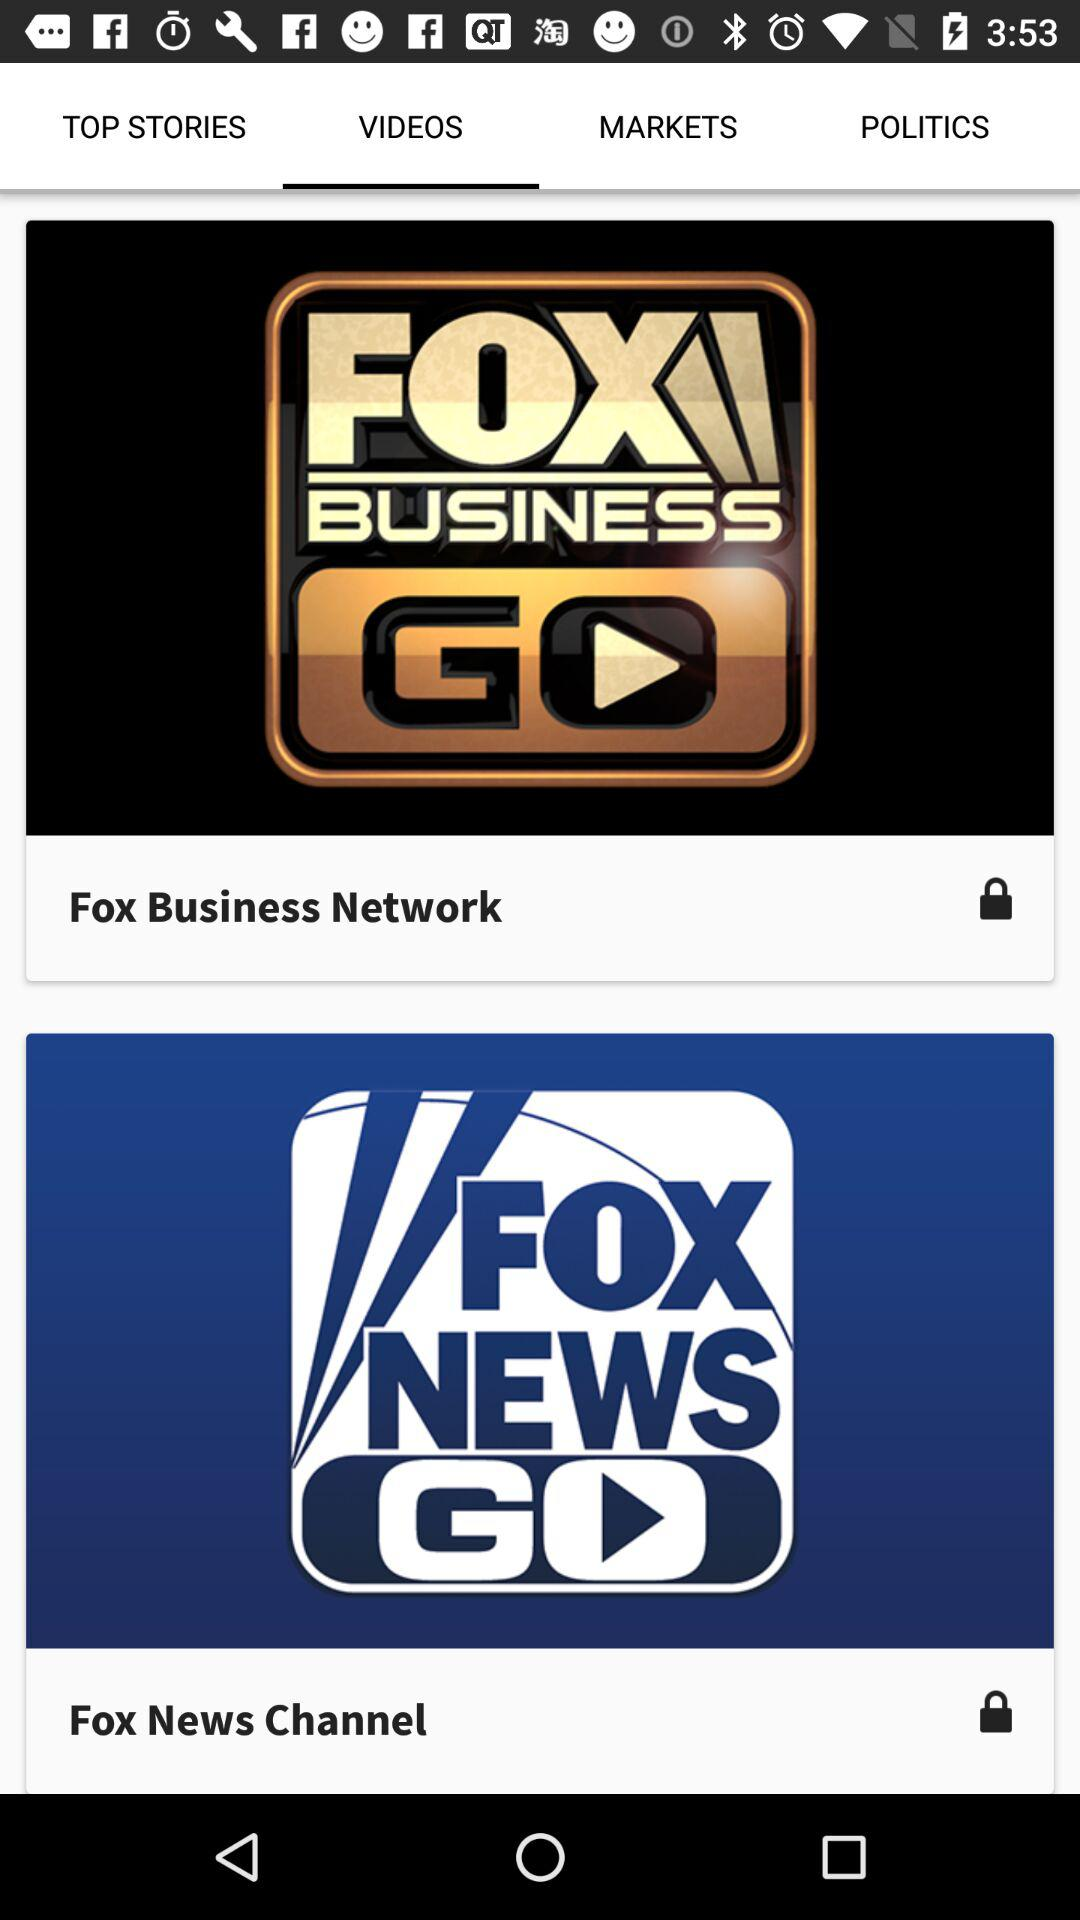Which tab is selected? The selected tab is "VIDEOS". 